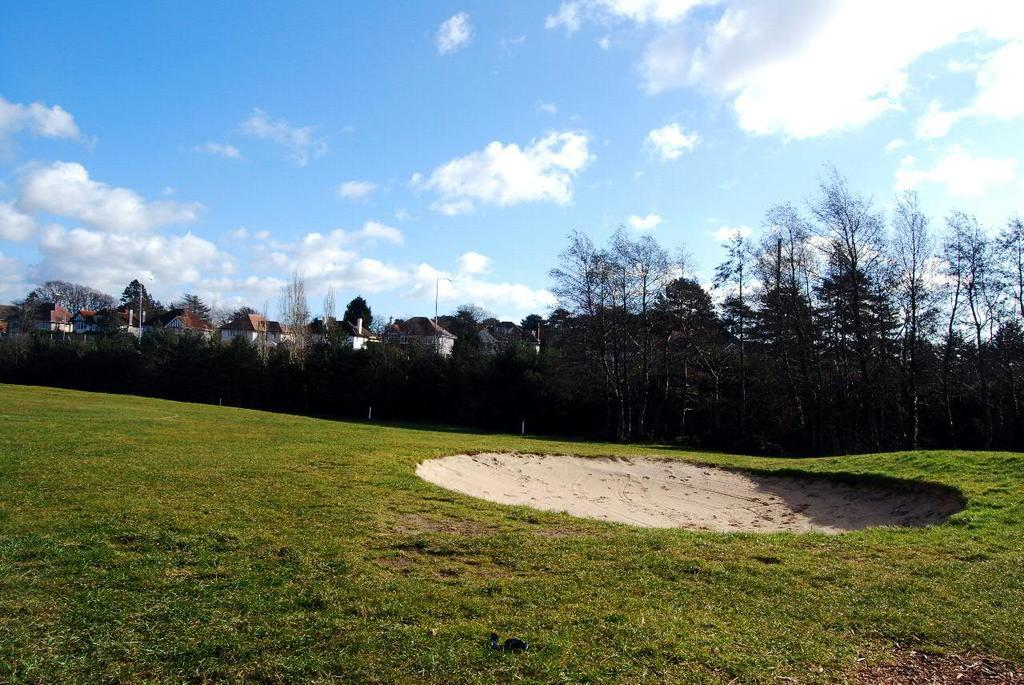What type of ground surface is visible in the image? There is grass on the ground in the image. What type of vegetation can be seen in the image? There are trees in the image. What structures are visible in the background of the image? There are houses in the background of the image. What is visible in the sky in the image? The sky is visible in the background of the image, and there are clouds in the sky. What type of camera is being used by the laborer in the image? There is no laborer or camera present in the image. 